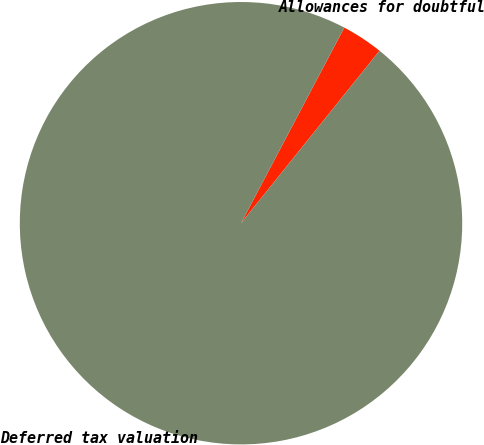Convert chart. <chart><loc_0><loc_0><loc_500><loc_500><pie_chart><fcel>Allowances for doubtful<fcel>Deferred tax valuation<nl><fcel>3.04%<fcel>96.96%<nl></chart> 